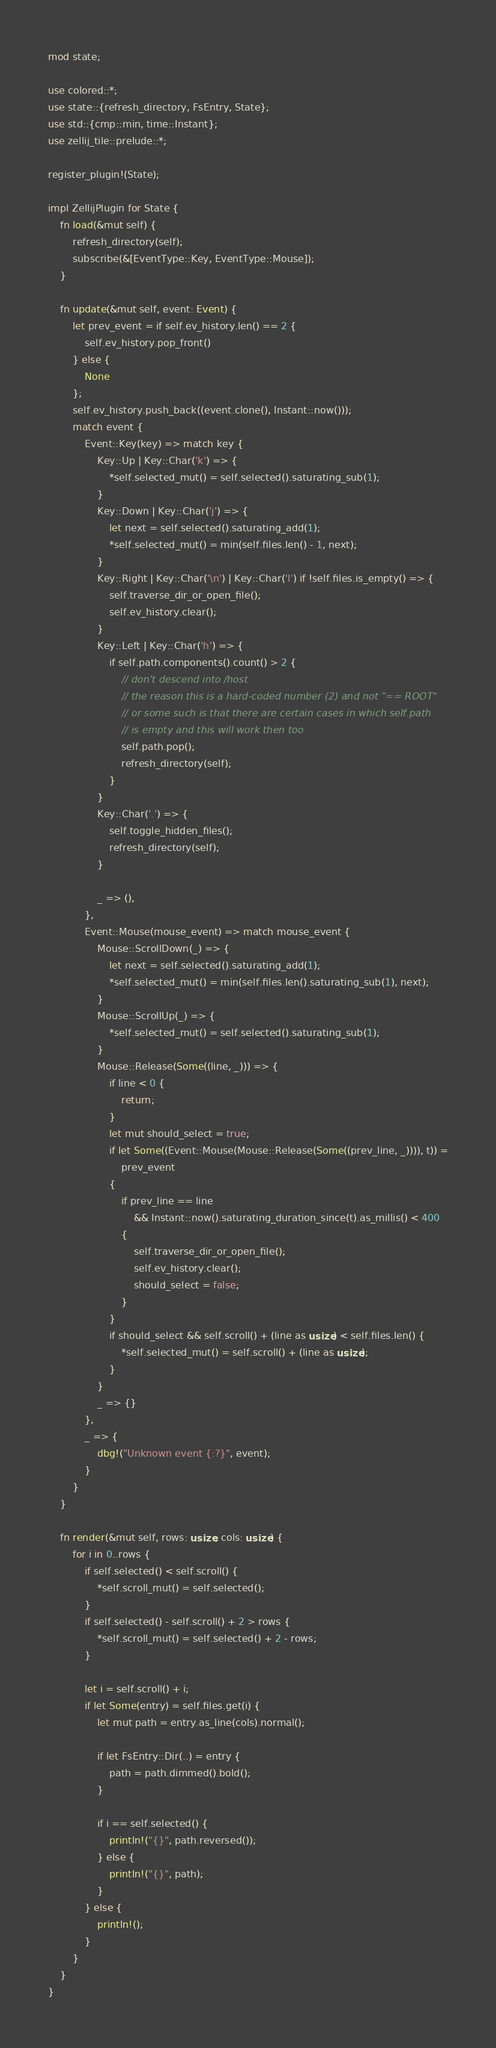Convert code to text. <code><loc_0><loc_0><loc_500><loc_500><_Rust_>mod state;

use colored::*;
use state::{refresh_directory, FsEntry, State};
use std::{cmp::min, time::Instant};
use zellij_tile::prelude::*;

register_plugin!(State);

impl ZellijPlugin for State {
    fn load(&mut self) {
        refresh_directory(self);
        subscribe(&[EventType::Key, EventType::Mouse]);
    }

    fn update(&mut self, event: Event) {
        let prev_event = if self.ev_history.len() == 2 {
            self.ev_history.pop_front()
        } else {
            None
        };
        self.ev_history.push_back((event.clone(), Instant::now()));
        match event {
            Event::Key(key) => match key {
                Key::Up | Key::Char('k') => {
                    *self.selected_mut() = self.selected().saturating_sub(1);
                }
                Key::Down | Key::Char('j') => {
                    let next = self.selected().saturating_add(1);
                    *self.selected_mut() = min(self.files.len() - 1, next);
                }
                Key::Right | Key::Char('\n') | Key::Char('l') if !self.files.is_empty() => {
                    self.traverse_dir_or_open_file();
                    self.ev_history.clear();
                }
                Key::Left | Key::Char('h') => {
                    if self.path.components().count() > 2 {
                        // don't descend into /host
                        // the reason this is a hard-coded number (2) and not "== ROOT"
                        // or some such is that there are certain cases in which self.path
                        // is empty and this will work then too
                        self.path.pop();
                        refresh_directory(self);
                    }
                }
                Key::Char('.') => {
                    self.toggle_hidden_files();
                    refresh_directory(self);
                }

                _ => (),
            },
            Event::Mouse(mouse_event) => match mouse_event {
                Mouse::ScrollDown(_) => {
                    let next = self.selected().saturating_add(1);
                    *self.selected_mut() = min(self.files.len().saturating_sub(1), next);
                }
                Mouse::ScrollUp(_) => {
                    *self.selected_mut() = self.selected().saturating_sub(1);
                }
                Mouse::Release(Some((line, _))) => {
                    if line < 0 {
                        return;
                    }
                    let mut should_select = true;
                    if let Some((Event::Mouse(Mouse::Release(Some((prev_line, _)))), t)) =
                        prev_event
                    {
                        if prev_line == line
                            && Instant::now().saturating_duration_since(t).as_millis() < 400
                        {
                            self.traverse_dir_or_open_file();
                            self.ev_history.clear();
                            should_select = false;
                        }
                    }
                    if should_select && self.scroll() + (line as usize) < self.files.len() {
                        *self.selected_mut() = self.scroll() + (line as usize);
                    }
                }
                _ => {}
            },
            _ => {
                dbg!("Unknown event {:?}", event);
            }
        }
    }

    fn render(&mut self, rows: usize, cols: usize) {
        for i in 0..rows {
            if self.selected() < self.scroll() {
                *self.scroll_mut() = self.selected();
            }
            if self.selected() - self.scroll() + 2 > rows {
                *self.scroll_mut() = self.selected() + 2 - rows;
            }

            let i = self.scroll() + i;
            if let Some(entry) = self.files.get(i) {
                let mut path = entry.as_line(cols).normal();

                if let FsEntry::Dir(..) = entry {
                    path = path.dimmed().bold();
                }

                if i == self.selected() {
                    println!("{}", path.reversed());
                } else {
                    println!("{}", path);
                }
            } else {
                println!();
            }
        }
    }
}
</code> 